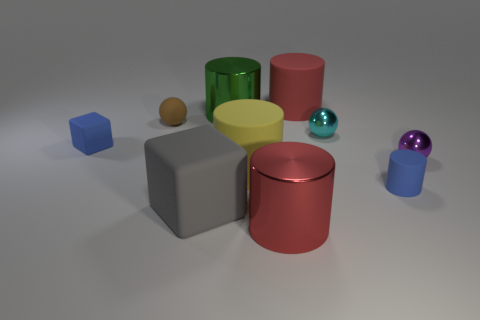Is there any particular light source that can be identified from the shadows and reflections in the image? Yes, the shadows and reflections suggest a single diffuse light source located somewhere above the objects, slightly to the center right of the scene. There is no harsh direct lighting, which indicates the light source might be softened, perhaps by a diffuser or due to indirect natural light. 